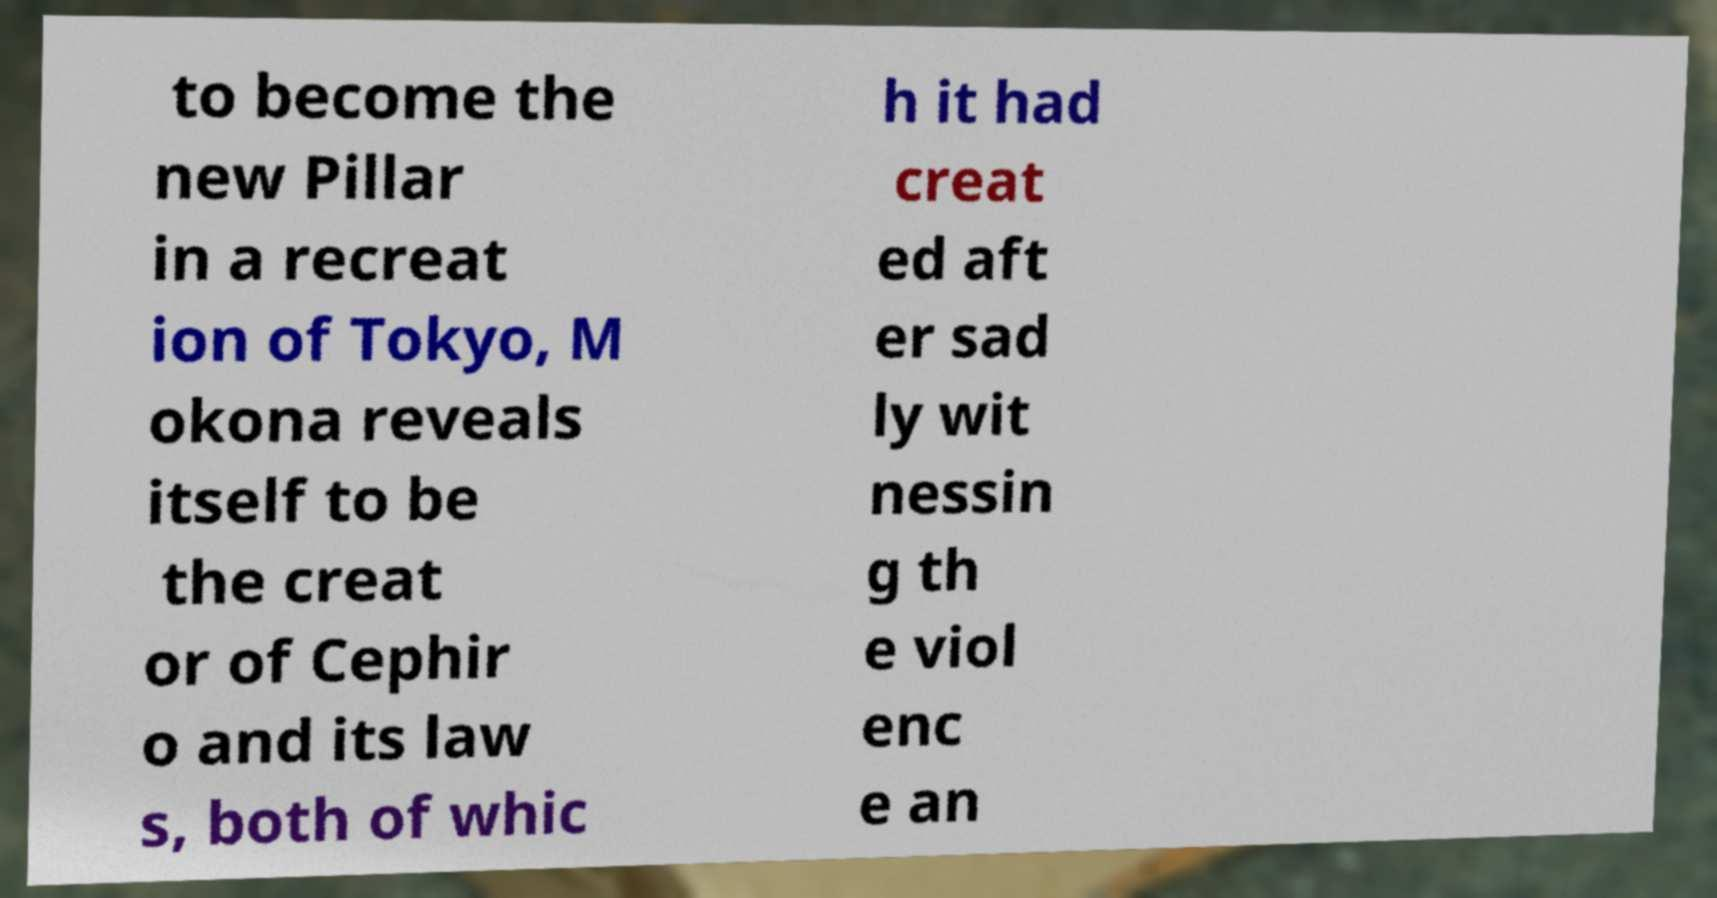There's text embedded in this image that I need extracted. Can you transcribe it verbatim? to become the new Pillar in a recreat ion of Tokyo, M okona reveals itself to be the creat or of Cephir o and its law s, both of whic h it had creat ed aft er sad ly wit nessin g th e viol enc e an 